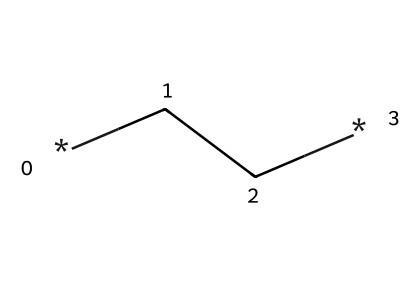How many carbon atoms are in this polymer? The SMILES representation "CC" indicates that there are two carbon atoms, as each "C" represents a carbon atom.
Answer: two What type of polymer is represented by this structure? The structure shown in the SMILES is indicative of polyethylene, a common thermoplastic polymer made from repeating units of ethene.
Answer: polyethylene What kind of bonding is predominant in this polymer? The chemical structure indicates that single bonds connect the carbon atoms in the chain, which is characteristic of polyethylene's saturated nature.
Answer: single bonds Is the structure branched or linear? The SMILES "CC" shows a straight chain of carbon atoms with no side groups or branches, indicating a linear structure typical of low-density polyethylene.
Answer: linear What property makes this polymer suitable for waterproof applications? Polyethylene's hydrophobic (water-repelling) nature, due to the absence of polar functional groups, contributes to its waterproof properties in products like tarps and sleeping bags.
Answer: hydrophobic How many hydrogen atoms are associated with the two carbons in this structure? Each carbon atom in a simple alkane like this one is bonded to hydrogen atoms. The two carbon atoms here will each be bonded to two hydrogen atoms (C2H4), meaning there are four hydrogen atoms total.
Answer: four 